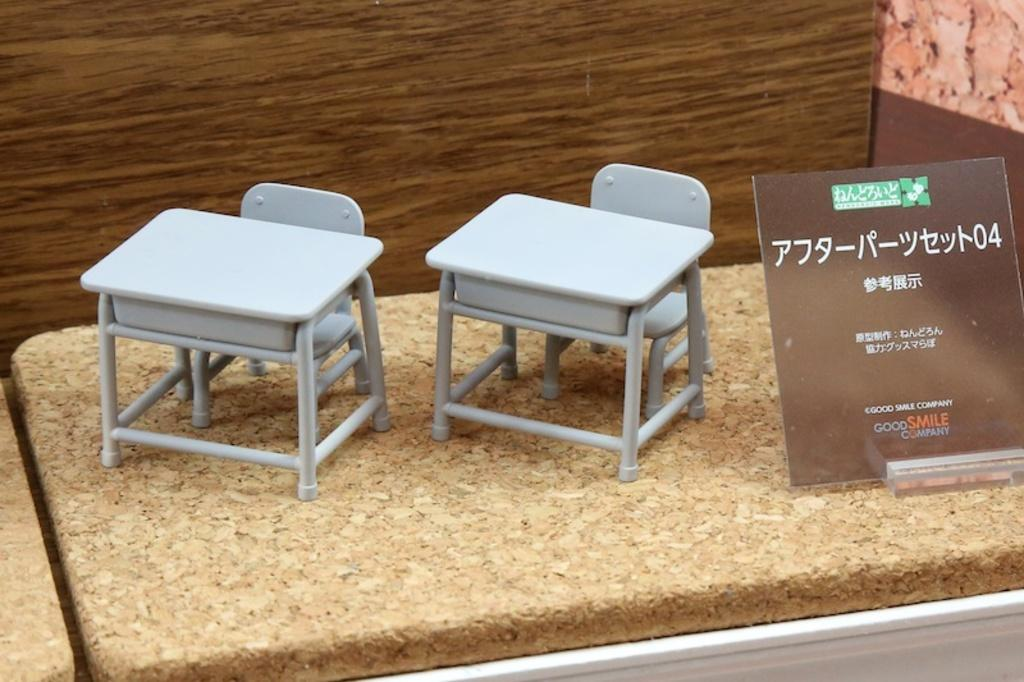What type of furniture is depicted in the image? There are miniature tables and chairs in the image. What is the surface on which the tables and chairs are placed? The tables and chairs are on a wooden surface. What else can be seen in the image besides the furniture? There is a board with text in the image. What is the background of the image made of? The background of the image is wooden. What color of paint is being used to destroy the miniature tables and chairs in the image? There is no paint or destruction present in the image; the tables and chairs are intact on a wooden surface. 